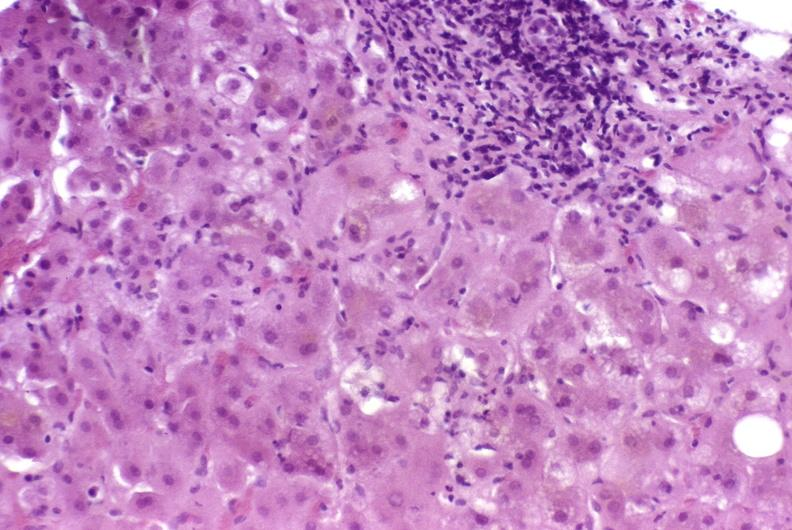does vasculature show autoimmune hepatitis?
Answer the question using a single word or phrase. No 